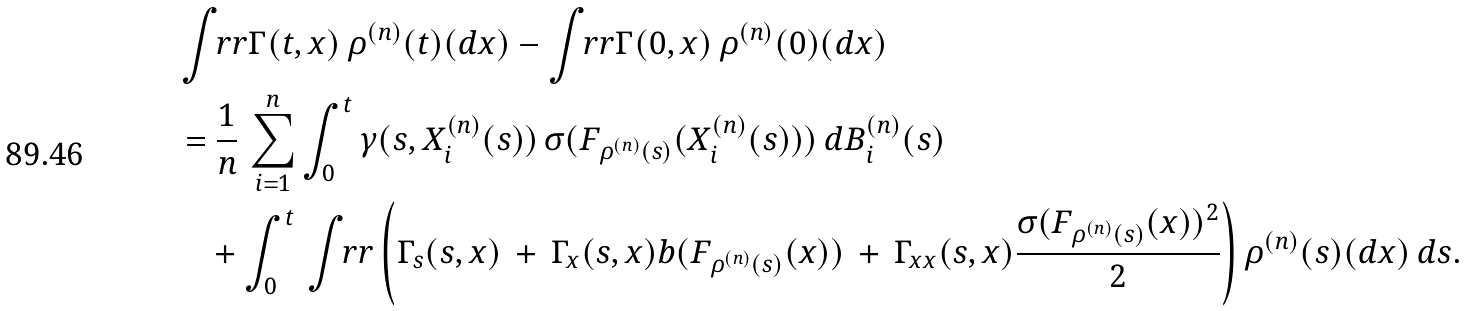<formula> <loc_0><loc_0><loc_500><loc_500>& \int _ { \ } r r \Gamma ( t , x ) \, \rho ^ { ( n ) } ( t ) ( d x ) - \int _ { \ } r r \Gamma ( 0 , x ) \, \rho ^ { ( n ) } ( 0 ) ( d x ) \\ & = \frac { 1 } { n } \, \sum _ { i = 1 } ^ { n } \int _ { 0 } ^ { t } \gamma ( s , X ^ { ( n ) } _ { i } ( s ) ) \, \sigma ( F _ { \rho ^ { ( n ) } ( s ) } ( X ^ { ( n ) } _ { i } ( s ) ) ) \, d B ^ { ( n ) } _ { i } ( s ) \\ & \quad + \int _ { 0 } ^ { t } \, \int _ { \ } r r \left ( \Gamma _ { s } ( s , x ) \, + \, \Gamma _ { x } ( s , x ) b ( F _ { \rho ^ { ( n ) } ( s ) } ( x ) ) \, + \, \Gamma _ { x x } ( s , x ) \frac { \sigma ( F _ { \rho ^ { ( n ) } ( s ) } ( x ) ) ^ { 2 } } { 2 } \right ) \rho ^ { ( n ) } ( s ) ( d x ) \, d s .</formula> 